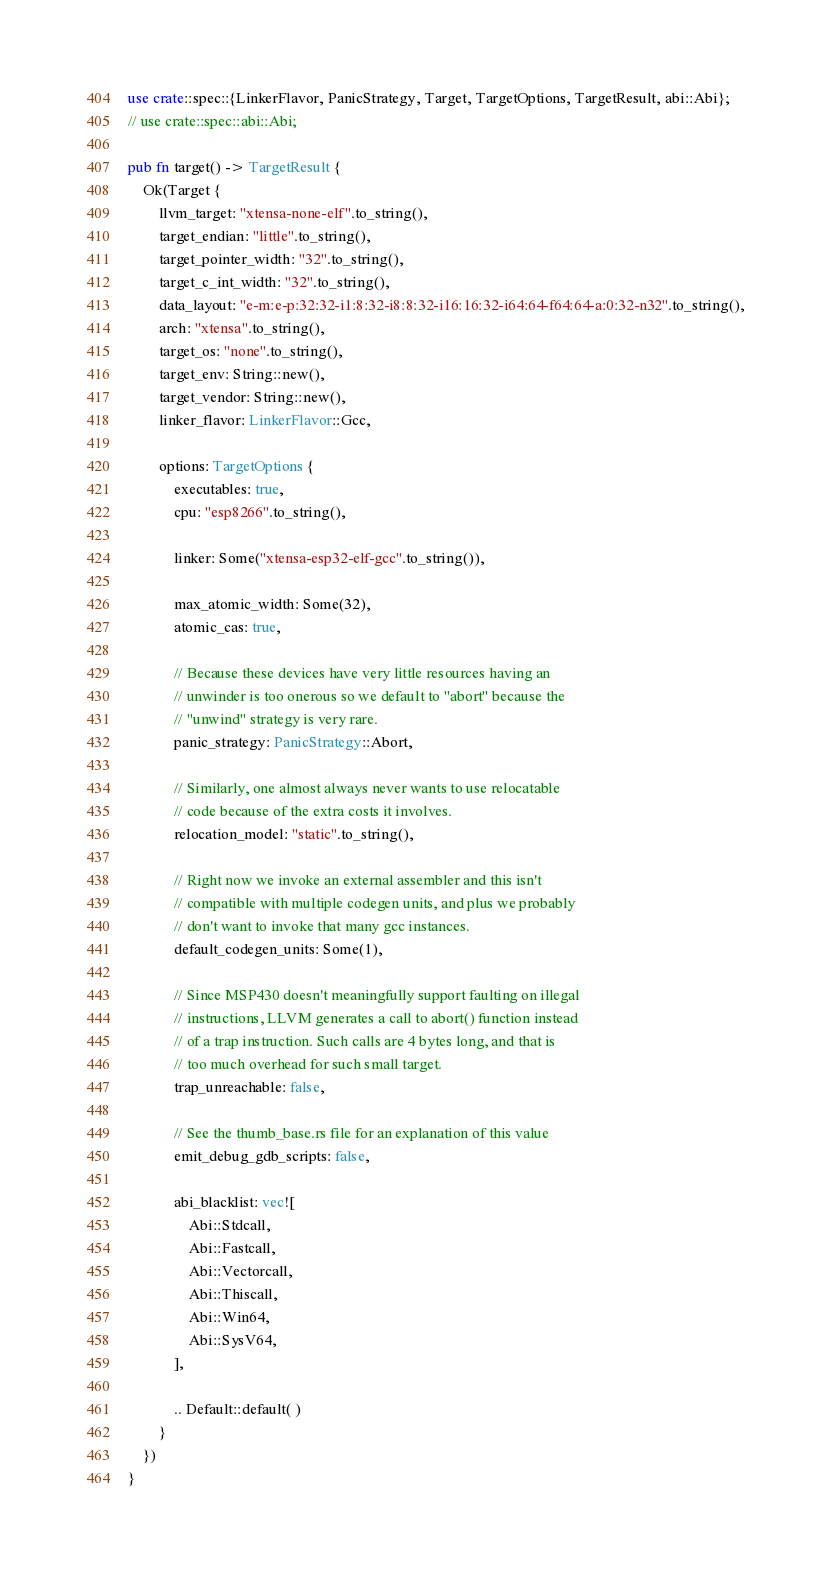<code> <loc_0><loc_0><loc_500><loc_500><_Rust_>use crate::spec::{LinkerFlavor, PanicStrategy, Target, TargetOptions, TargetResult, abi::Abi}; 
// use crate::spec::abi::Abi;

pub fn target() -> TargetResult {
    Ok(Target {
        llvm_target: "xtensa-none-elf".to_string(),
        target_endian: "little".to_string(),
        target_pointer_width: "32".to_string(),
        target_c_int_width: "32".to_string(),
        data_layout: "e-m:e-p:32:32-i1:8:32-i8:8:32-i16:16:32-i64:64-f64:64-a:0:32-n32".to_string(),
        arch: "xtensa".to_string(),
        target_os: "none".to_string(),
        target_env: String::new(),
        target_vendor: String::new(),
        linker_flavor: LinkerFlavor::Gcc,

        options: TargetOptions {
            executables: true,
            cpu: "esp8266".to_string(),

            linker: Some("xtensa-esp32-elf-gcc".to_string()),

            max_atomic_width: Some(32),
            atomic_cas: true,

            // Because these devices have very little resources having an
            // unwinder is too onerous so we default to "abort" because the
            // "unwind" strategy is very rare.
            panic_strategy: PanicStrategy::Abort,

            // Similarly, one almost always never wants to use relocatable
            // code because of the extra costs it involves.
            relocation_model: "static".to_string(),

            // Right now we invoke an external assembler and this isn't
            // compatible with multiple codegen units, and plus we probably
            // don't want to invoke that many gcc instances.
            default_codegen_units: Some(1),

            // Since MSP430 doesn't meaningfully support faulting on illegal
            // instructions, LLVM generates a call to abort() function instead
            // of a trap instruction. Such calls are 4 bytes long, and that is
            // too much overhead for such small target.
            trap_unreachable: false,

            // See the thumb_base.rs file for an explanation of this value
            emit_debug_gdb_scripts: false,

            abi_blacklist: vec![
                Abi::Stdcall,
                Abi::Fastcall,
                Abi::Vectorcall,
                Abi::Thiscall,
                Abi::Win64,
                Abi::SysV64,
            ],

            .. Default::default( )
        }
    })
}
</code> 